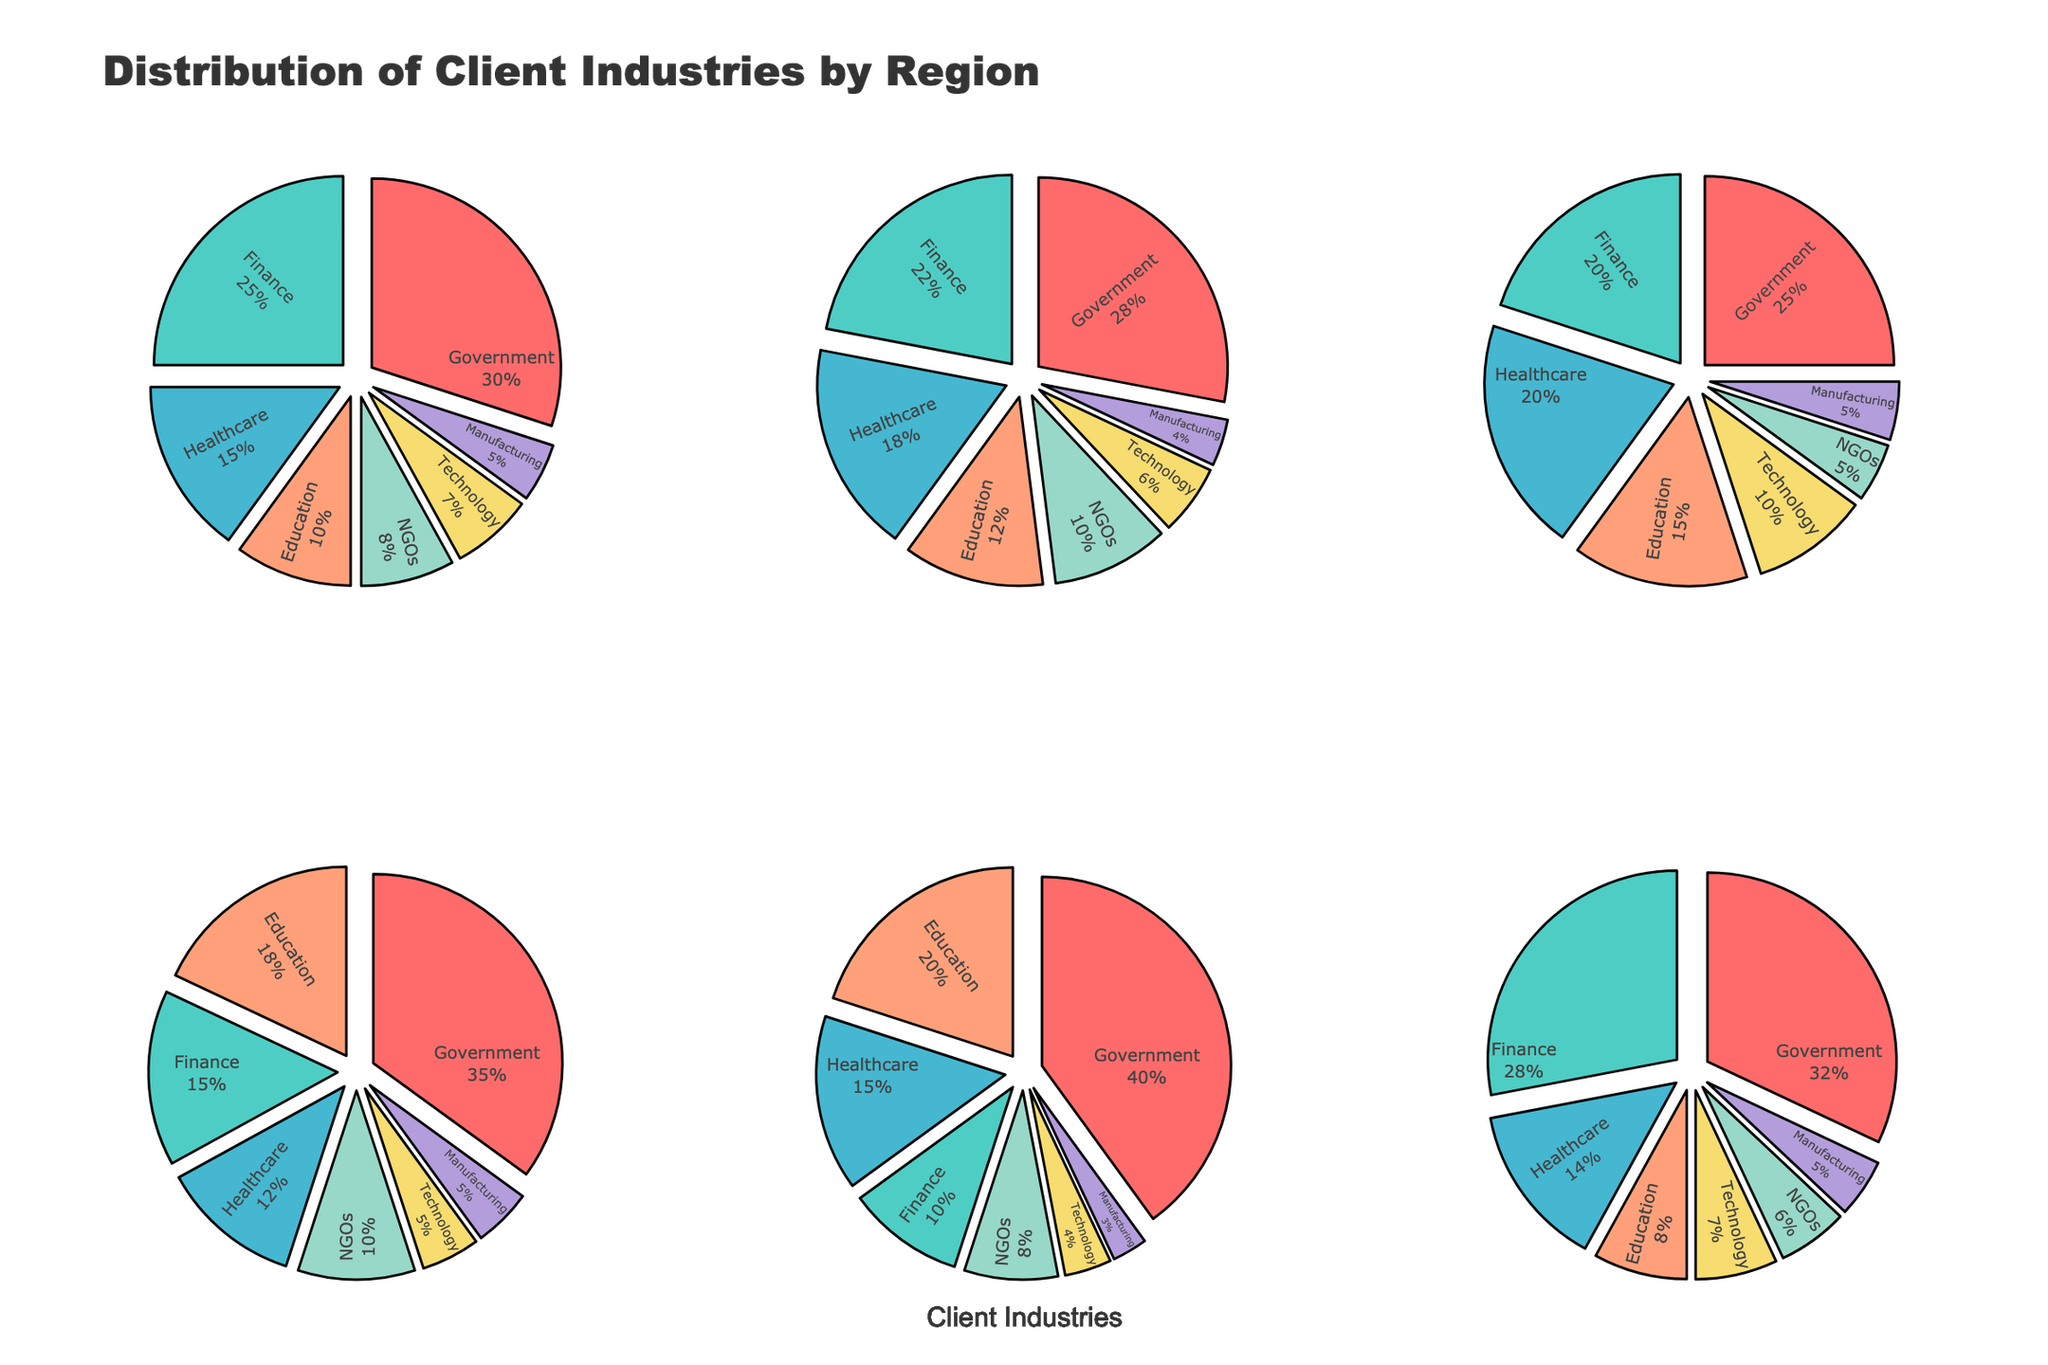What is the most common client industry in North America? By examining the North America's pie chart, we see the largest slice representing Government at 30%.
Answer: Government Which region has the highest percentage of clients in the Technology industry? By examining each pie chart, we find that Asia Pacific has the highest percentage in Technology at 10%.
Answer: Asia Pacific What is the combined percentage of Education and NGOs for Europe? Adding the percentages of Education (12%) and NGOs (10%) in the Europe pie chart gives 12% + 10% = 22%.
Answer: 22% In which region does the Healthcare sector contribute the highest percentage? By checking each pie chart, we observe that the Asia Pacific region has the highest percentage at 20%.
Answer: Asia Pacific Compare the Finance sector percentages between North America and Middle East. Which one is higher and by how much? North America has Finance at 25% and the Middle East at 28%. The Middle East is higher by 3%.
Answer: Middle East by 3% Which region has the smallest percentage of Manufacturing clients? Looking at all pie charts, Africa has the smallest percentage in Manufacturing at 3%.
Answer: Africa What is the percentage difference between the Government sector in Latin America and Africa? Africa has Government at 40% and Latin America at 35%. The difference is 40% - 35 = 5%.
Answer: 5% Summing up the NGO and Technology sectors, which region has the smallest percentage combined? For each region:
- North America: 8% + 7% = 15%
- Europe: 10% + 6% = 16%
- Asia Pacific: 5% + 10% = 15%
- Latin America: 10% + 5% = 15%
- Africa: 8% + 4% = 12%
- Middle East: 6% + 7% = 13%
Africa has the smallest combined percentage at 12%.
Answer: Africa How does the distribution of the Finance sector compare to the Government sector in the Middle East? In the Middle East pie chart, Finance is at 28% and Government at 32%. Government has a slightly higher percentage by 4%.
Answer: Government by 4% Which region has a more even distribution among the five sectors (excluding the Manufacturing and Technology sectors)? Examining the pie charts, Asia Pacific shows a more balanced distribution among Government, Finance, Healthcare, Education, and NGOs sectors, with percentages ranging from 5% to 25%.
Answer: Asia Pacific 